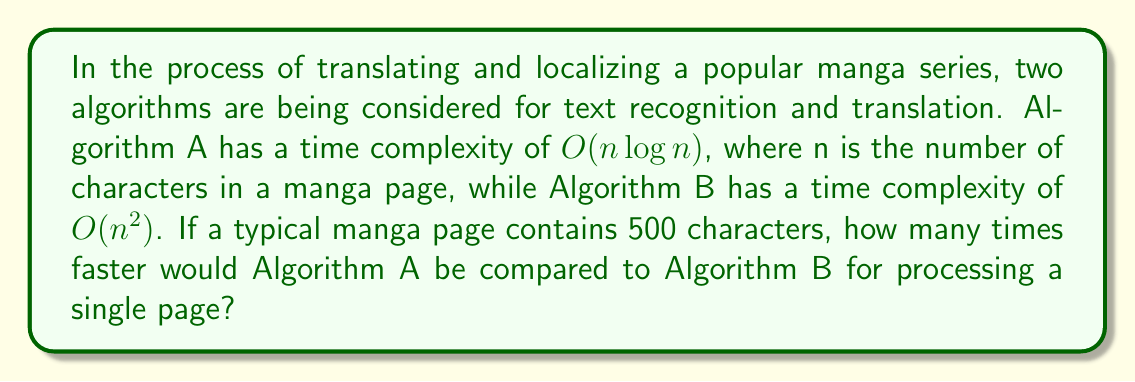Teach me how to tackle this problem. To solve this problem, we need to compare the running times of both algorithms for n = 500 characters. Let's break it down step-by-step:

1. For Algorithm A with $O(n \log n)$ complexity:
   Running time ≈ $c_1 \cdot n \log n$
   where $c_1$ is some constant factor.

2. For Algorithm B with $O(n^2)$ complexity:
   Running time ≈ $c_2 \cdot n^2$
   where $c_2$ is some constant factor.

3. Let's assume $c_1 = c_2 = 1$ for simplicity. The actual values don't affect the ratio.

4. For n = 500:
   Algorithm A: $500 \log 500 \approx 500 \cdot 8.97 = 4,485$
   Algorithm B: $500^2 = 250,000$

5. To find how many times faster Algorithm A is, we divide:
   $$\frac{\text{Time for Algorithm B}}{\text{Time for Algorithm A}} = \frac{250,000}{4,485} \approx 55.74$$

Therefore, Algorithm A would be approximately 55.74 times faster than Algorithm B for processing a single manga page with 500 characters.
Answer: Algorithm A would be approximately 55.74 times faster than Algorithm B. 